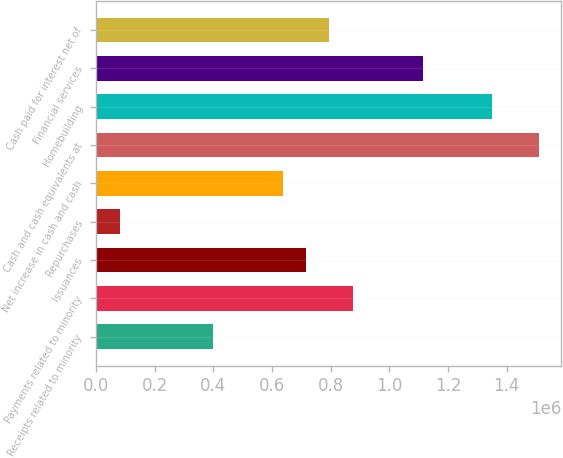Convert chart to OTSL. <chart><loc_0><loc_0><loc_500><loc_500><bar_chart><fcel>Receipts related to minority<fcel>Payments related to minority<fcel>Issuances<fcel>Repurchases<fcel>Net increase in cash and cash<fcel>Cash and cash equivalents at<fcel>Homebuilding<fcel>Financial services<fcel>Cash paid for interest net of<nl><fcel>398410<fcel>874551<fcel>715837<fcel>80981.9<fcel>636480<fcel>1.50941e+06<fcel>1.35069e+06<fcel>1.11262e+06<fcel>795194<nl></chart> 